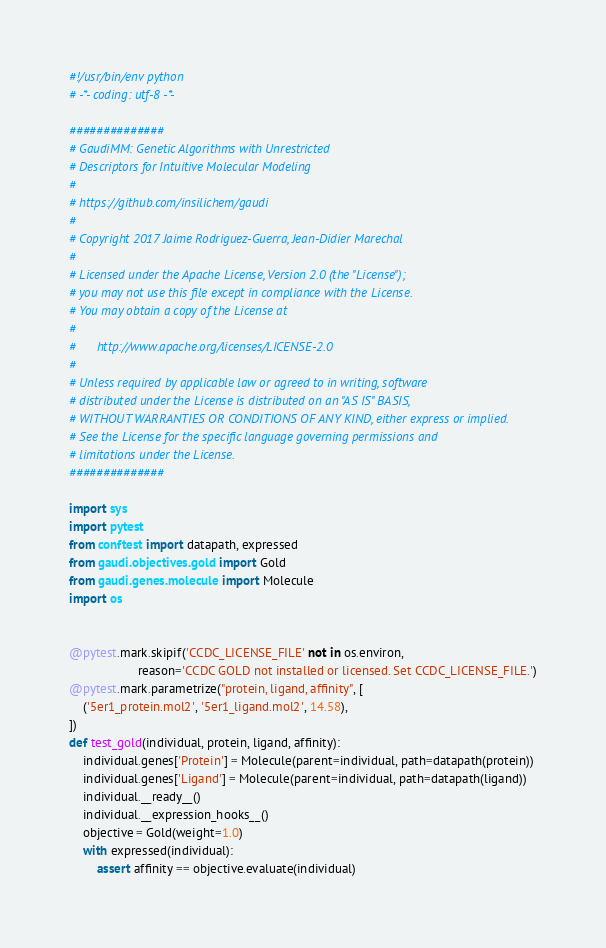Convert code to text. <code><loc_0><loc_0><loc_500><loc_500><_Python_>#!/usr/bin/env python
# -*- coding: utf-8 -*-

##############
# GaudiMM: Genetic Algorithms with Unrestricted
# Descriptors for Intuitive Molecular Modeling
#
# https://github.com/insilichem/gaudi
#
# Copyright 2017 Jaime Rodriguez-Guerra, Jean-Didier Marechal
#
# Licensed under the Apache License, Version 2.0 (the "License");
# you may not use this file except in compliance with the License.
# You may obtain a copy of the License at
#
#      http://www.apache.org/licenses/LICENSE-2.0
#
# Unless required by applicable law or agreed to in writing, software
# distributed under the License is distributed on an "AS IS" BASIS,
# WITHOUT WARRANTIES OR CONDITIONS OF ANY KIND, either express or implied.
# See the License for the specific language governing permissions and
# limitations under the License.
##############

import sys
import pytest
from conftest import datapath, expressed
from gaudi.objectives.gold import Gold
from gaudi.genes.molecule import Molecule
import os


@pytest.mark.skipif('CCDC_LICENSE_FILE' not in os.environ,
                    reason='CCDC GOLD not installed or licensed. Set CCDC_LICENSE_FILE.')
@pytest.mark.parametrize("protein, ligand, affinity", [
    ('5er1_protein.mol2', '5er1_ligand.mol2', 14.58),
])
def test_gold(individual, protein, ligand, affinity):
    individual.genes['Protein'] = Molecule(parent=individual, path=datapath(protein))
    individual.genes['Ligand'] = Molecule(parent=individual, path=datapath(ligand))
    individual.__ready__()
    individual.__expression_hooks__()
    objective = Gold(weight=1.0)
    with expressed(individual):
        assert affinity == objective.evaluate(individual)</code> 